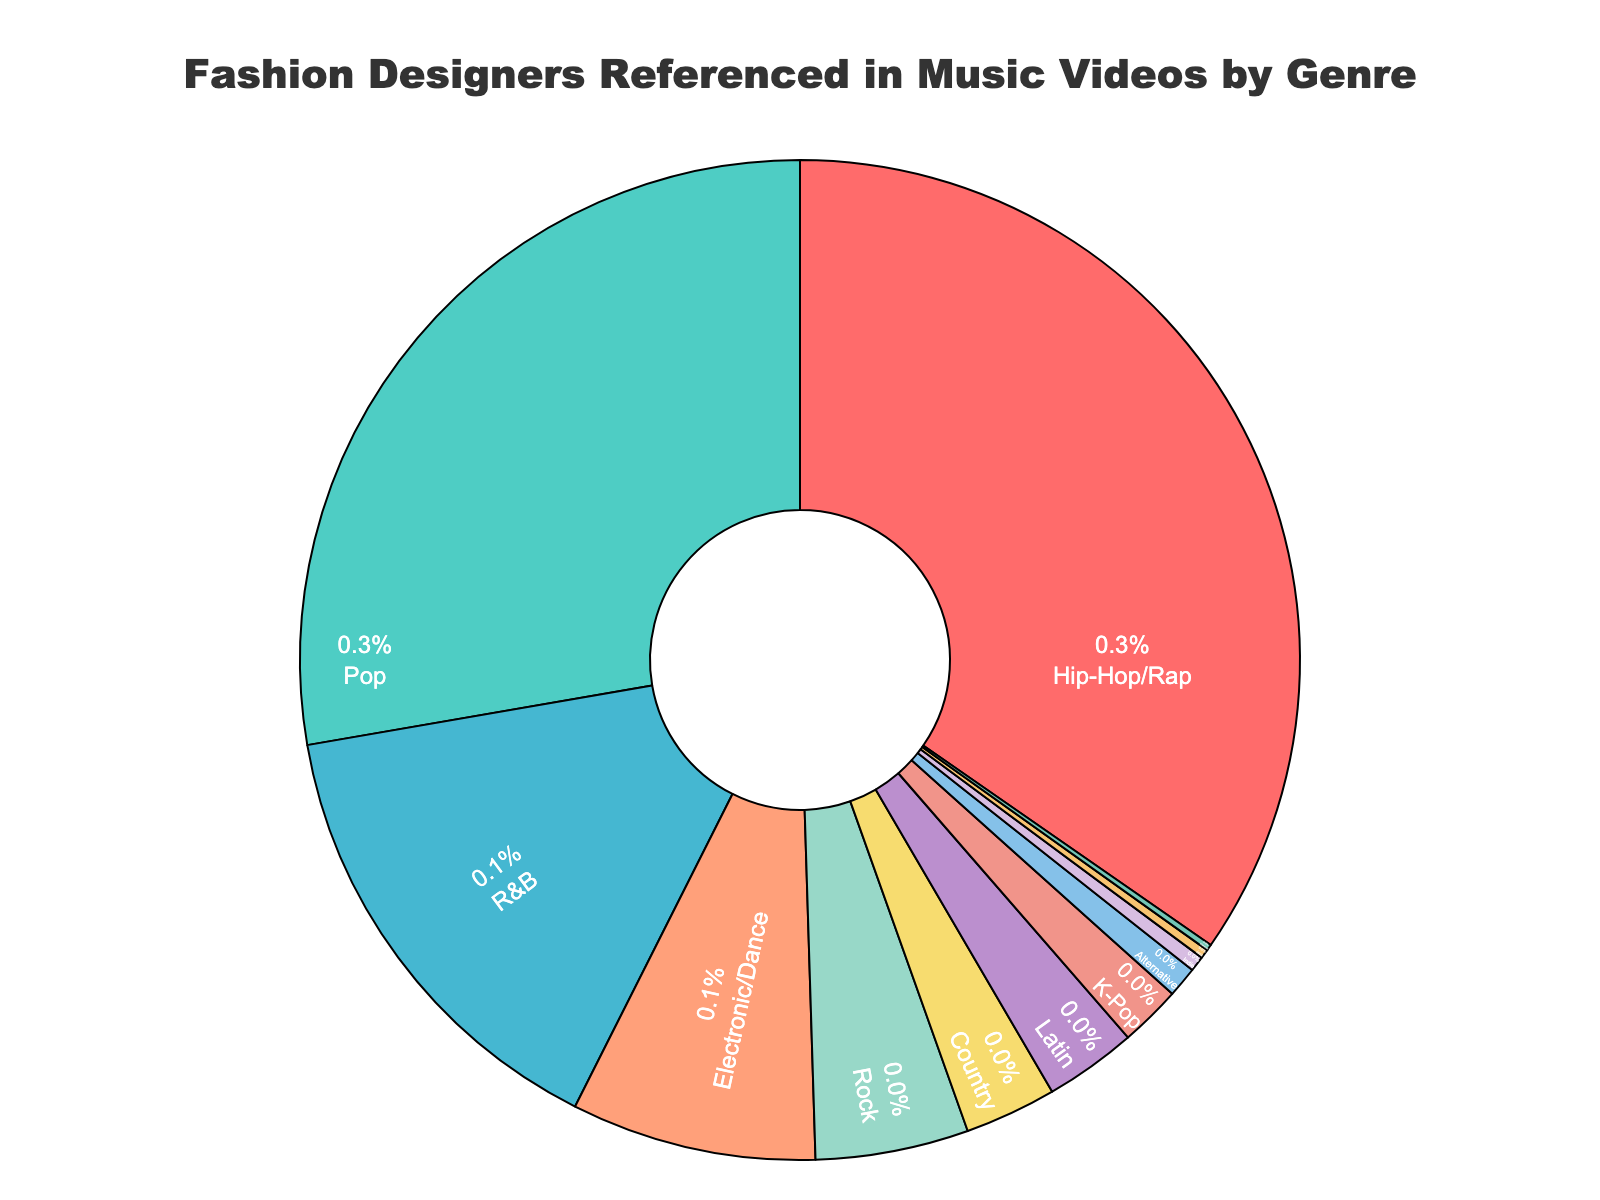What genre has the highest percentage of fashion designers referenced in music videos? The genre with the largest slice in the pie chart represents the highest percentage. According to the chart, Hip-Hop/Rap has the biggest slice.
Answer: Hip-Hop/Rap Which genres have an equal percentage of fashion designers referenced? Look for slices that are of equal size and percentages listed in the chart; Country and Latin both have 3%.
Answer: Country and Latin How much more percentage does Hip-Hop/Rap have compared to Pop? Subtract the percentage of Pop from Hip-Hop/Rap: 35% (Hip-Hop/Rap) - 28% (Pop) = 7%.
Answer: 7% What is the combined percentage of genres that have less than 5% each? Add the percentages of genres less than 5%: Rock 5%, Country 3%, Latin 3%, K-Pop 2%, Alternative 1%, Indie 0.5%, Jazz 0.3%, Classical 0.2%. Combined total: 15%.
Answer: 15% Which genre has the lowest percentage of fashion designers referenced? Look at the segment with the smallest slice in the pie chart, which represents the genre with the lowest percentage. Classical has the smallest percentage at 0.2%.
Answer: Classical What's the total percentage of fashion designers referenced in music videos across Electronic/Dance, Rock, and R&B genres? Sum the percentages of the specified genres: Electronic/Dance 8%, Rock 5%, R&B 15%. Combined total: 28%.
Answer: 28% How does the percentage of R&B compare to Electronic/Dance and Rock combined? Compare R&B's percentage to the combined percentage of Electronic/Dance and Rock: R&B (15%) is equal to the combined 13% of Electronic/Dance (8%) and Rock (5%).
Answer: 15% R&B is more than 13% Which genre has a higher percentage of fashion designers referenced, K-Pop or Alternative? Compare the slices for K-Pop and Alternative in the pie chart: K-Pop has 2%, while Alternative has 1%.
Answer: K-Pop What is the visual attribute used to differentiate the genres in the pie chart? Different colors are used to represent each genre in the pie chart for differentiation purposes.
Answer: Colors 